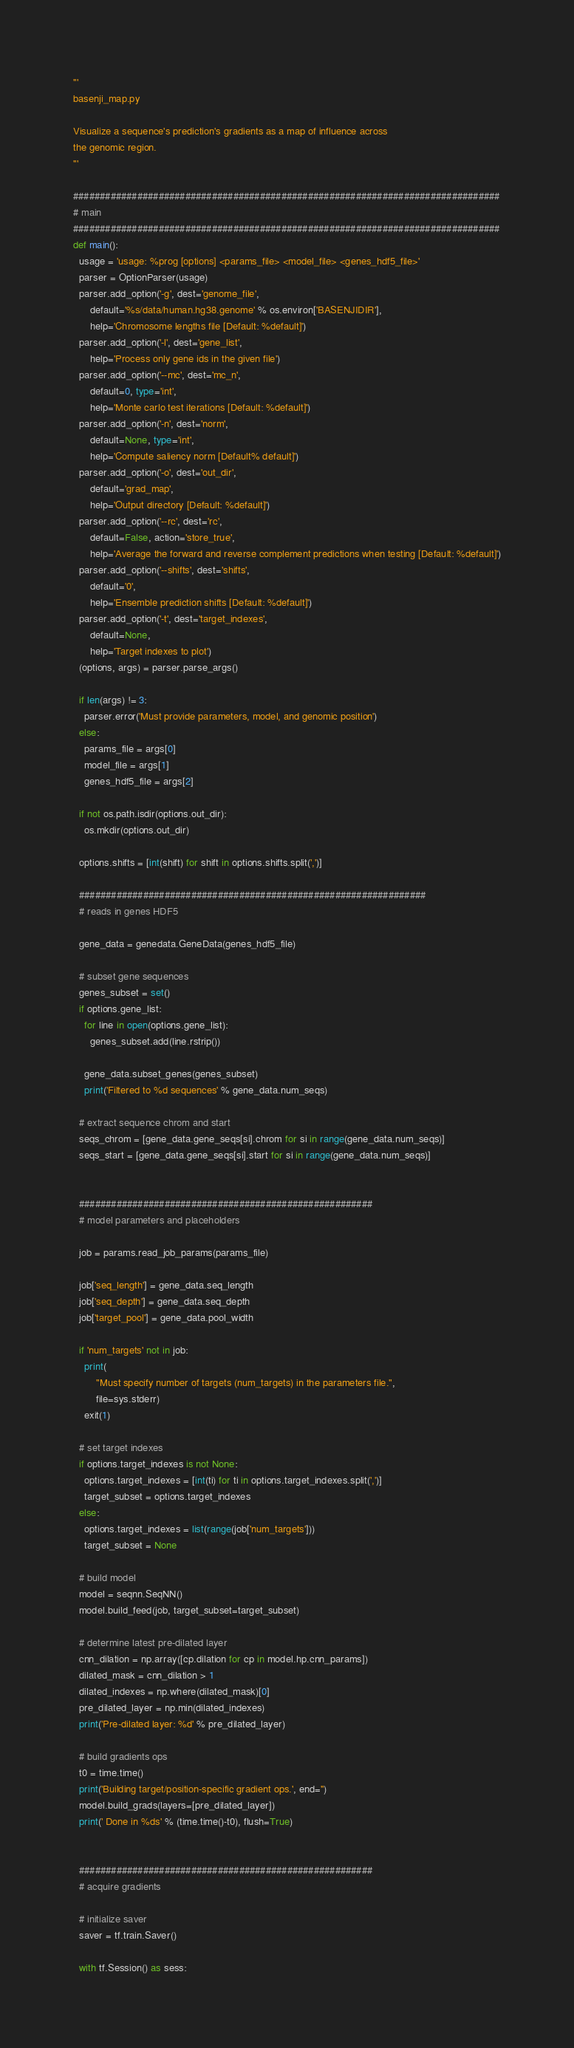<code> <loc_0><loc_0><loc_500><loc_500><_Python_>'''
basenji_map.py

Visualize a sequence's prediction's gradients as a map of influence across
the genomic region.
'''

################################################################################
# main
################################################################################
def main():
  usage = 'usage: %prog [options] <params_file> <model_file> <genes_hdf5_file>'
  parser = OptionParser(usage)
  parser.add_option('-g', dest='genome_file',
      default='%s/data/human.hg38.genome' % os.environ['BASENJIDIR'],
      help='Chromosome lengths file [Default: %default]')
  parser.add_option('-l', dest='gene_list',
      help='Process only gene ids in the given file')
  parser.add_option('--mc', dest='mc_n',
      default=0, type='int',
      help='Monte carlo test iterations [Default: %default]')
  parser.add_option('-n', dest='norm',
      default=None, type='int',
      help='Compute saliency norm [Default% default]')
  parser.add_option('-o', dest='out_dir',
      default='grad_map',
      help='Output directory [Default: %default]')
  parser.add_option('--rc', dest='rc',
      default=False, action='store_true',
      help='Average the forward and reverse complement predictions when testing [Default: %default]')
  parser.add_option('--shifts', dest='shifts',
      default='0',
      help='Ensemble prediction shifts [Default: %default]')
  parser.add_option('-t', dest='target_indexes',
      default=None,
      help='Target indexes to plot')
  (options, args) = parser.parse_args()

  if len(args) != 3:
    parser.error('Must provide parameters, model, and genomic position')
  else:
    params_file = args[0]
    model_file = args[1]
    genes_hdf5_file = args[2]

  if not os.path.isdir(options.out_dir):
    os.mkdir(options.out_dir)

  options.shifts = [int(shift) for shift in options.shifts.split(',')]

  #################################################################
  # reads in genes HDF5

  gene_data = genedata.GeneData(genes_hdf5_file)

  # subset gene sequences
  genes_subset = set()
  if options.gene_list:
    for line in open(options.gene_list):
      genes_subset.add(line.rstrip())

    gene_data.subset_genes(genes_subset)
    print('Filtered to %d sequences' % gene_data.num_seqs)

  # extract sequence chrom and start
  seqs_chrom = [gene_data.gene_seqs[si].chrom for si in range(gene_data.num_seqs)]
  seqs_start = [gene_data.gene_seqs[si].start for si in range(gene_data.num_seqs)]


  #######################################################
  # model parameters and placeholders

  job = params.read_job_params(params_file)

  job['seq_length'] = gene_data.seq_length
  job['seq_depth'] = gene_data.seq_depth
  job['target_pool'] = gene_data.pool_width

  if 'num_targets' not in job:
    print(
        "Must specify number of targets (num_targets) in the parameters file.",
        file=sys.stderr)
    exit(1)

  # set target indexes
  if options.target_indexes is not None:
    options.target_indexes = [int(ti) for ti in options.target_indexes.split(',')]
    target_subset = options.target_indexes
  else:
    options.target_indexes = list(range(job['num_targets']))
    target_subset = None

  # build model
  model = seqnn.SeqNN()
  model.build_feed(job, target_subset=target_subset)

  # determine latest pre-dilated layer
  cnn_dilation = np.array([cp.dilation for cp in model.hp.cnn_params])
  dilated_mask = cnn_dilation > 1
  dilated_indexes = np.where(dilated_mask)[0]
  pre_dilated_layer = np.min(dilated_indexes)
  print('Pre-dilated layer: %d' % pre_dilated_layer)

  # build gradients ops
  t0 = time.time()
  print('Building target/position-specific gradient ops.', end='')
  model.build_grads(layers=[pre_dilated_layer])
  print(' Done in %ds' % (time.time()-t0), flush=True)


  #######################################################
  # acquire gradients

  # initialize saver
  saver = tf.train.Saver()

  with tf.Session() as sess:</code> 